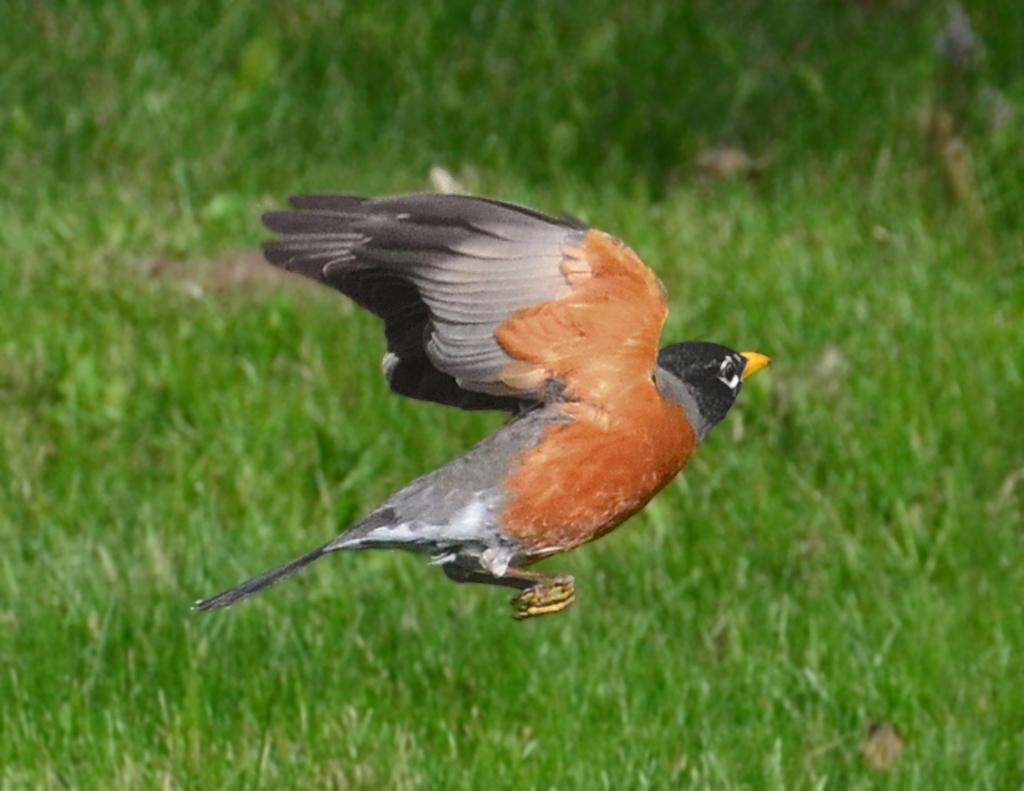What type of animal can be seen in the image? There is a bird in the image. What is the bird doing in the image? The bird is flying. What colors can be observed on the bird? The bird is black and orange in color. What type of terrain is visible in the image? There is grass on the ground in the image. What type of cake is being served at the pet's birthday party in the image? There is no cake or pet present in the image, so it is not possible to answer that question. 